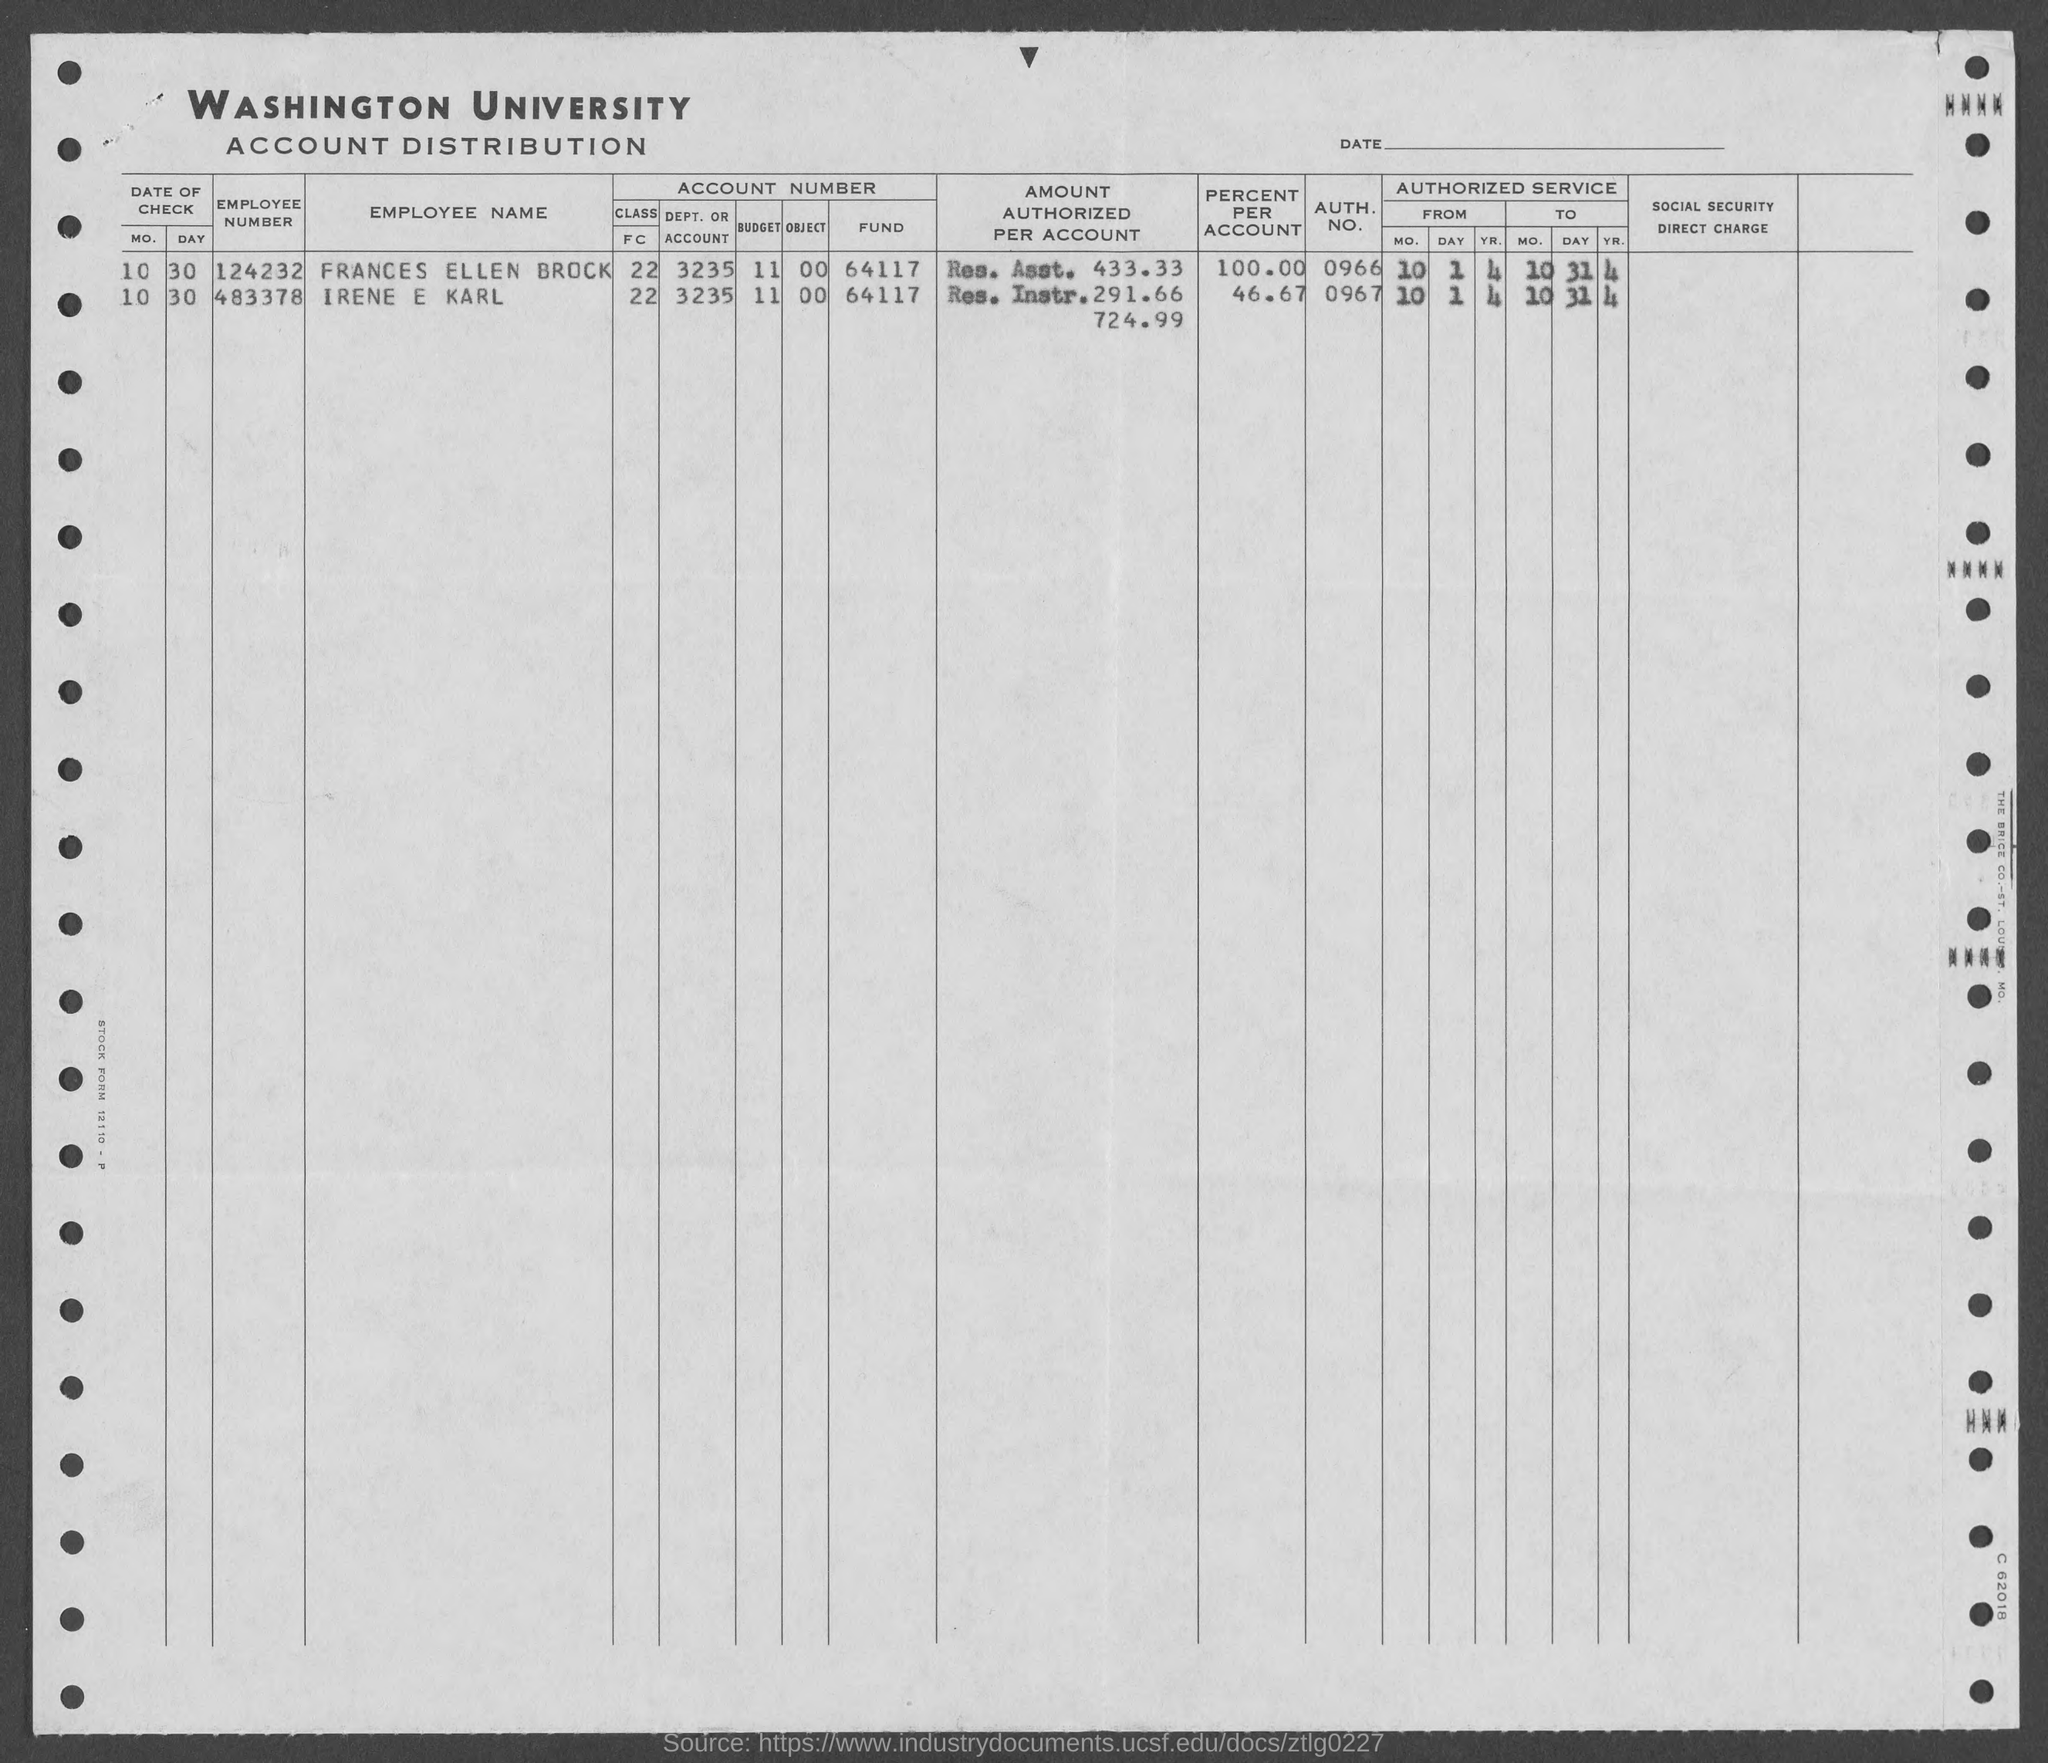what is the auth. no. for irene e karl ?
 0967 